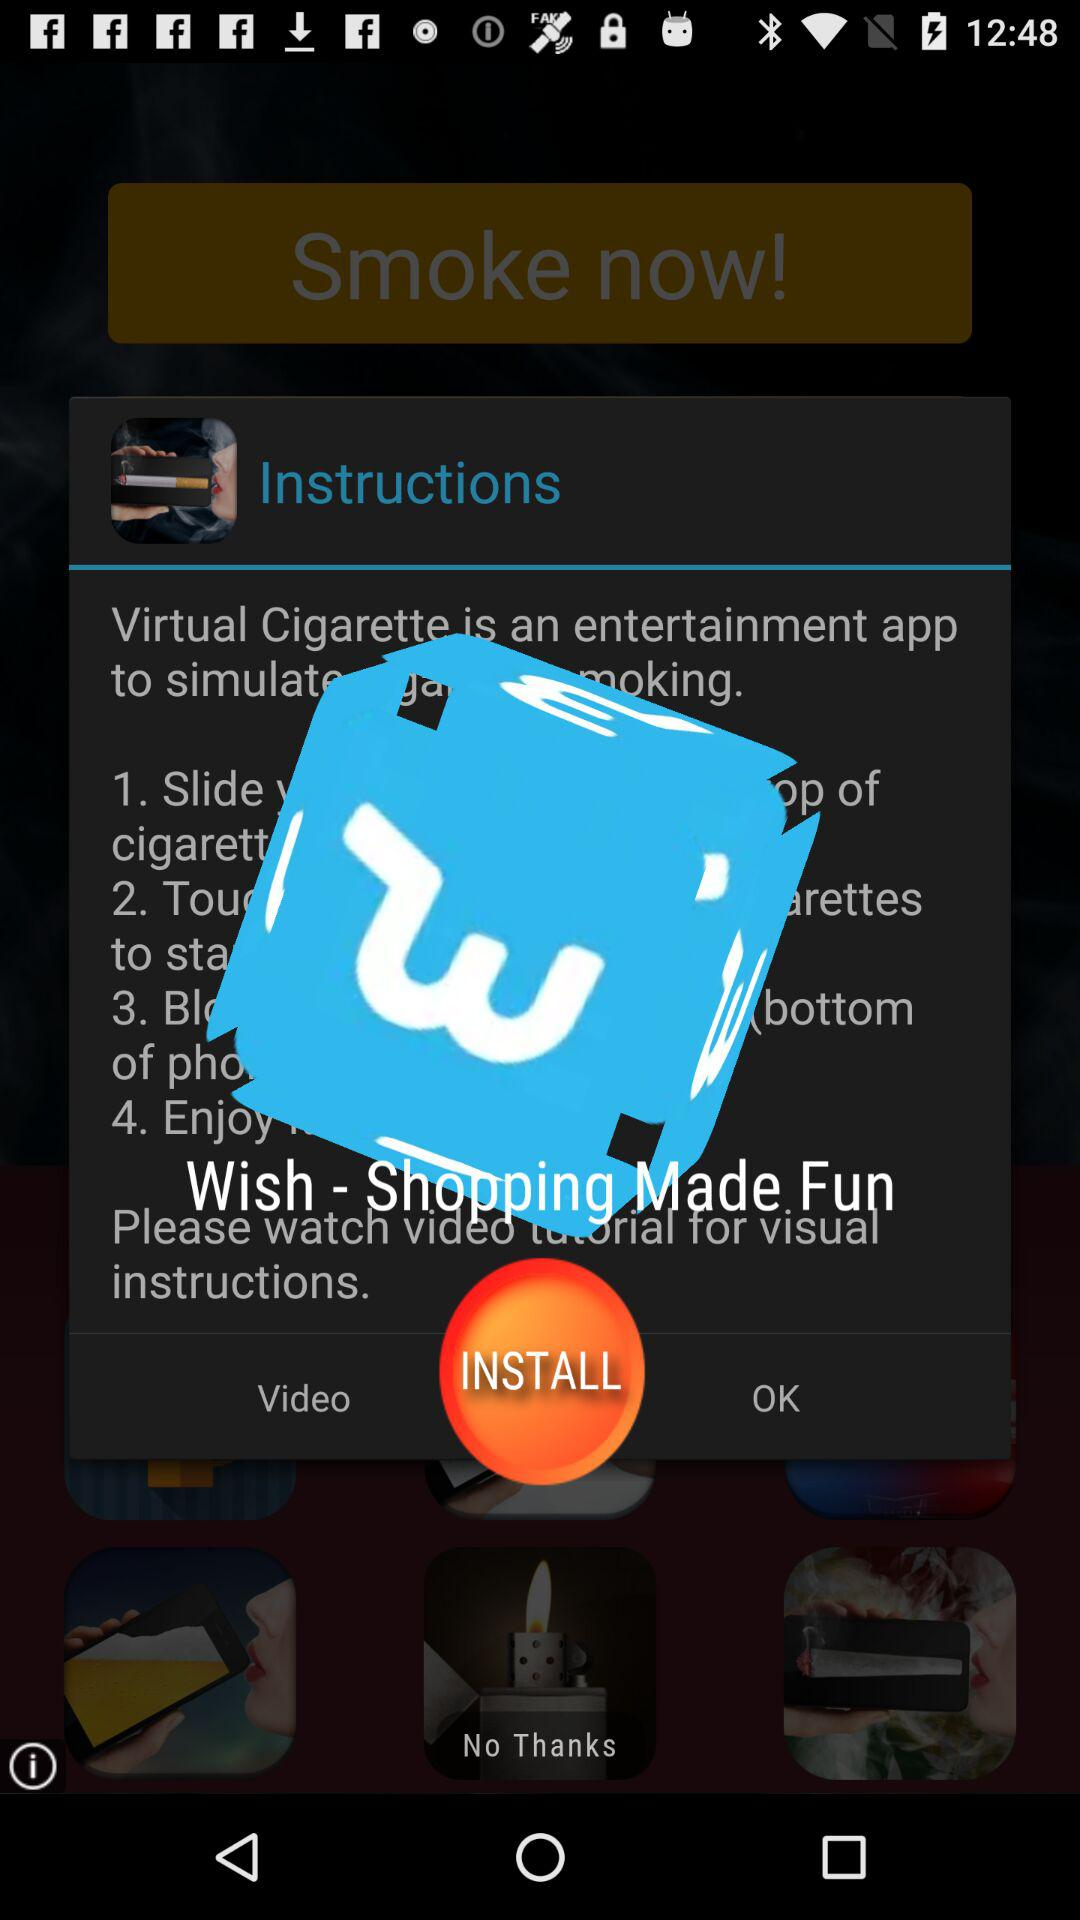How many instructions are there for how to use the app?
Answer the question using a single word or phrase. 4 